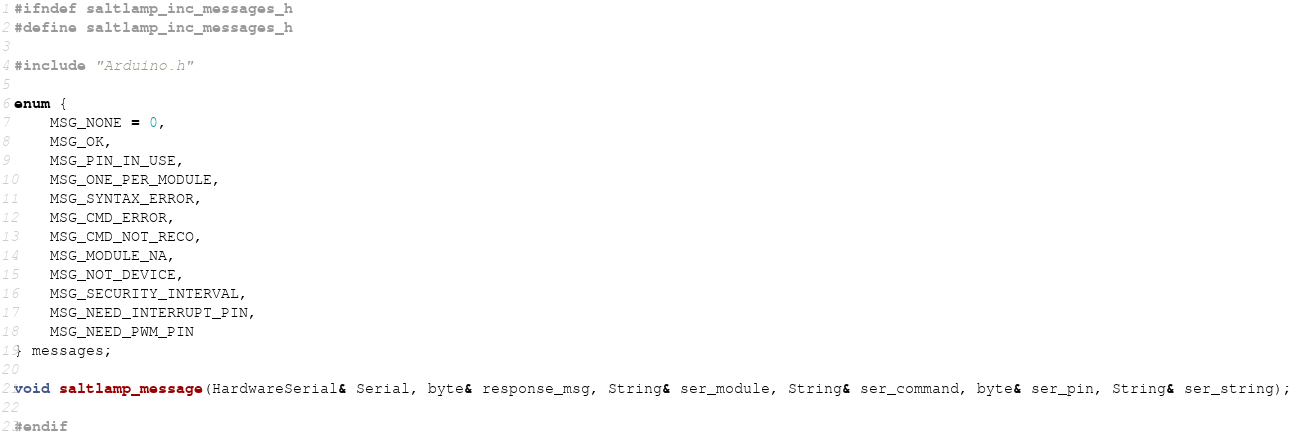<code> <loc_0><loc_0><loc_500><loc_500><_C_>#ifndef saltlamp_inc_messages_h
#define saltlamp_inc_messages_h

#include "Arduino.h"

enum {
	MSG_NONE = 0,
	MSG_OK,
	MSG_PIN_IN_USE,
	MSG_ONE_PER_MODULE,
	MSG_SYNTAX_ERROR,
	MSG_CMD_ERROR,
	MSG_CMD_NOT_RECO,
	MSG_MODULE_NA,
	MSG_NOT_DEVICE,
	MSG_SECURITY_INTERVAL,
	MSG_NEED_INTERRUPT_PIN,
	MSG_NEED_PWM_PIN
} messages;

void saltlamp_message(HardwareSerial& Serial, byte& response_msg, String& ser_module, String& ser_command, byte& ser_pin, String& ser_string);

#endif</code> 